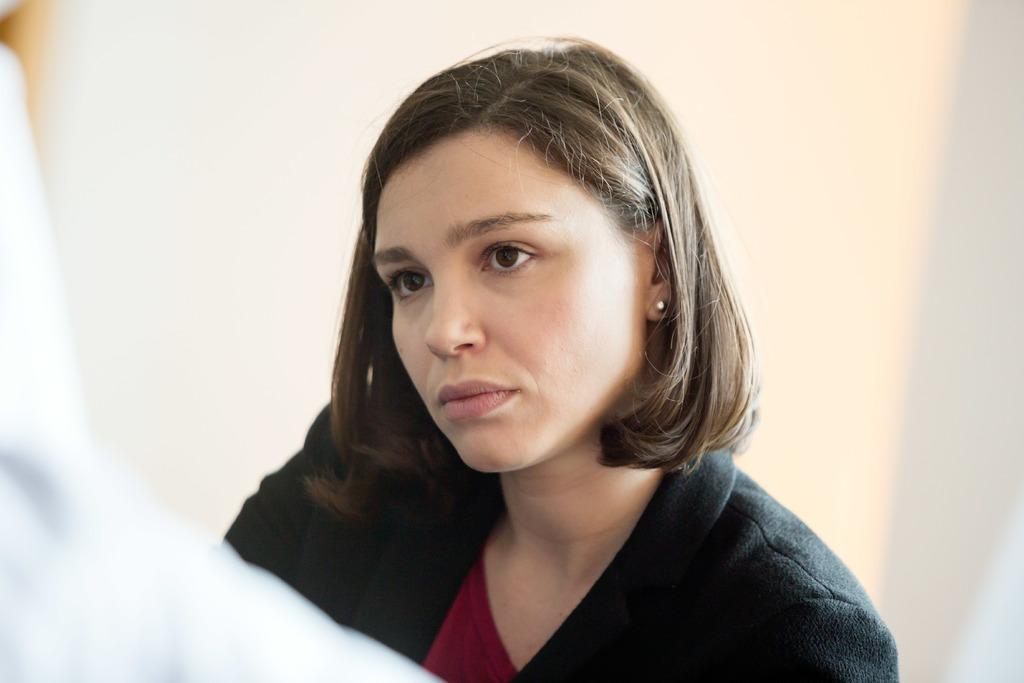Who is the main subject in the image? There is a woman in the image. What is the woman wearing? The woman is wearing a black coat. What is the color of the background in the image? The background of the image is white. What type of mark can be seen on the woman's face in the image? There is no mark visible on the woman's face in the image. Is there any fire or destruction present in the image? No, there is no fire or destruction present in the image. 